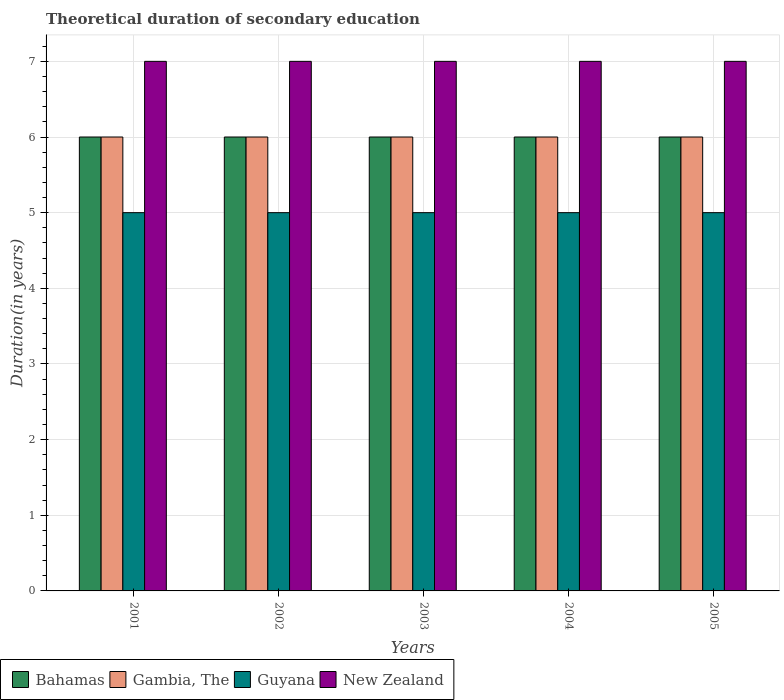How many bars are there on the 5th tick from the left?
Your answer should be compact. 4. How many bars are there on the 4th tick from the right?
Ensure brevity in your answer.  4. What is the label of the 4th group of bars from the left?
Keep it short and to the point. 2004. What is the total theoretical duration of secondary education in Gambia, The in 2004?
Your response must be concise. 6. Across all years, what is the maximum total theoretical duration of secondary education in New Zealand?
Offer a terse response. 7. In which year was the total theoretical duration of secondary education in Bahamas minimum?
Offer a very short reply. 2001. What is the total total theoretical duration of secondary education in Guyana in the graph?
Your response must be concise. 25. What is the difference between the total theoretical duration of secondary education in Bahamas in 2001 and that in 2005?
Provide a succinct answer. 0. In how many years, is the total theoretical duration of secondary education in Gambia, The greater than 1.6 years?
Make the answer very short. 5. Is the difference between the total theoretical duration of secondary education in Gambia, The in 2002 and 2005 greater than the difference between the total theoretical duration of secondary education in Bahamas in 2002 and 2005?
Keep it short and to the point. No. What is the difference between the highest and the second highest total theoretical duration of secondary education in Bahamas?
Your response must be concise. 0. What is the difference between the highest and the lowest total theoretical duration of secondary education in Gambia, The?
Offer a very short reply. 0. In how many years, is the total theoretical duration of secondary education in Gambia, The greater than the average total theoretical duration of secondary education in Gambia, The taken over all years?
Provide a short and direct response. 0. What does the 4th bar from the left in 2001 represents?
Provide a succinct answer. New Zealand. What does the 3rd bar from the right in 2002 represents?
Offer a terse response. Gambia, The. Is it the case that in every year, the sum of the total theoretical duration of secondary education in New Zealand and total theoretical duration of secondary education in Guyana is greater than the total theoretical duration of secondary education in Bahamas?
Provide a succinct answer. Yes. Are all the bars in the graph horizontal?
Give a very brief answer. No. How many years are there in the graph?
Your response must be concise. 5. What is the difference between two consecutive major ticks on the Y-axis?
Provide a short and direct response. 1. Are the values on the major ticks of Y-axis written in scientific E-notation?
Offer a terse response. No. Does the graph contain any zero values?
Give a very brief answer. No. Does the graph contain grids?
Ensure brevity in your answer.  Yes. How are the legend labels stacked?
Your answer should be very brief. Horizontal. What is the title of the graph?
Your answer should be very brief. Theoretical duration of secondary education. Does "Philippines" appear as one of the legend labels in the graph?
Provide a succinct answer. No. What is the label or title of the X-axis?
Your answer should be very brief. Years. What is the label or title of the Y-axis?
Keep it short and to the point. Duration(in years). What is the Duration(in years) of Gambia, The in 2001?
Your response must be concise. 6. What is the Duration(in years) in Guyana in 2001?
Give a very brief answer. 5. What is the Duration(in years) of Gambia, The in 2002?
Make the answer very short. 6. What is the Duration(in years) in Guyana in 2002?
Your answer should be compact. 5. What is the Duration(in years) in New Zealand in 2002?
Your response must be concise. 7. What is the Duration(in years) of Gambia, The in 2003?
Provide a succinct answer. 6. What is the Duration(in years) of Guyana in 2003?
Give a very brief answer. 5. What is the Duration(in years) of New Zealand in 2004?
Offer a terse response. 7. What is the Duration(in years) of Bahamas in 2005?
Your answer should be very brief. 6. What is the Duration(in years) of Gambia, The in 2005?
Your answer should be very brief. 6. What is the Duration(in years) of Guyana in 2005?
Your answer should be very brief. 5. Across all years, what is the maximum Duration(in years) of Bahamas?
Provide a short and direct response. 6. Across all years, what is the maximum Duration(in years) of Gambia, The?
Your response must be concise. 6. Across all years, what is the maximum Duration(in years) in New Zealand?
Ensure brevity in your answer.  7. Across all years, what is the minimum Duration(in years) in New Zealand?
Make the answer very short. 7. What is the total Duration(in years) in Bahamas in the graph?
Offer a very short reply. 30. What is the total Duration(in years) in Gambia, The in the graph?
Your response must be concise. 30. What is the total Duration(in years) of Guyana in the graph?
Offer a very short reply. 25. What is the difference between the Duration(in years) of Gambia, The in 2001 and that in 2002?
Provide a short and direct response. 0. What is the difference between the Duration(in years) of Guyana in 2001 and that in 2002?
Keep it short and to the point. 0. What is the difference between the Duration(in years) in New Zealand in 2001 and that in 2002?
Your answer should be very brief. 0. What is the difference between the Duration(in years) of Bahamas in 2001 and that in 2003?
Provide a succinct answer. 0. What is the difference between the Duration(in years) in Gambia, The in 2001 and that in 2003?
Provide a succinct answer. 0. What is the difference between the Duration(in years) in Guyana in 2001 and that in 2003?
Offer a terse response. 0. What is the difference between the Duration(in years) in Bahamas in 2001 and that in 2004?
Provide a short and direct response. 0. What is the difference between the Duration(in years) of Gambia, The in 2001 and that in 2005?
Ensure brevity in your answer.  0. What is the difference between the Duration(in years) in Gambia, The in 2002 and that in 2003?
Give a very brief answer. 0. What is the difference between the Duration(in years) of Guyana in 2002 and that in 2003?
Your response must be concise. 0. What is the difference between the Duration(in years) of New Zealand in 2002 and that in 2003?
Offer a terse response. 0. What is the difference between the Duration(in years) in Gambia, The in 2002 and that in 2004?
Give a very brief answer. 0. What is the difference between the Duration(in years) in Guyana in 2002 and that in 2004?
Offer a very short reply. 0. What is the difference between the Duration(in years) of Bahamas in 2002 and that in 2005?
Your response must be concise. 0. What is the difference between the Duration(in years) in Gambia, The in 2002 and that in 2005?
Offer a very short reply. 0. What is the difference between the Duration(in years) in Guyana in 2002 and that in 2005?
Offer a very short reply. 0. What is the difference between the Duration(in years) in New Zealand in 2002 and that in 2005?
Your response must be concise. 0. What is the difference between the Duration(in years) of Bahamas in 2003 and that in 2004?
Ensure brevity in your answer.  0. What is the difference between the Duration(in years) of Gambia, The in 2003 and that in 2004?
Your answer should be very brief. 0. What is the difference between the Duration(in years) of Bahamas in 2003 and that in 2005?
Provide a short and direct response. 0. What is the difference between the Duration(in years) in New Zealand in 2003 and that in 2005?
Keep it short and to the point. 0. What is the difference between the Duration(in years) of Gambia, The in 2004 and that in 2005?
Provide a succinct answer. 0. What is the difference between the Duration(in years) of Bahamas in 2001 and the Duration(in years) of Gambia, The in 2002?
Your response must be concise. 0. What is the difference between the Duration(in years) of Bahamas in 2001 and the Duration(in years) of Guyana in 2002?
Provide a short and direct response. 1. What is the difference between the Duration(in years) of Gambia, The in 2001 and the Duration(in years) of Guyana in 2002?
Offer a very short reply. 1. What is the difference between the Duration(in years) of Bahamas in 2001 and the Duration(in years) of Gambia, The in 2003?
Offer a very short reply. 0. What is the difference between the Duration(in years) of Bahamas in 2001 and the Duration(in years) of Gambia, The in 2004?
Give a very brief answer. 0. What is the difference between the Duration(in years) of Bahamas in 2001 and the Duration(in years) of Guyana in 2004?
Offer a terse response. 1. What is the difference between the Duration(in years) of Guyana in 2001 and the Duration(in years) of New Zealand in 2004?
Your answer should be compact. -2. What is the difference between the Duration(in years) in Gambia, The in 2001 and the Duration(in years) in Guyana in 2005?
Keep it short and to the point. 1. What is the difference between the Duration(in years) of Gambia, The in 2001 and the Duration(in years) of New Zealand in 2005?
Provide a succinct answer. -1. What is the difference between the Duration(in years) of Guyana in 2001 and the Duration(in years) of New Zealand in 2005?
Give a very brief answer. -2. What is the difference between the Duration(in years) of Gambia, The in 2002 and the Duration(in years) of Guyana in 2003?
Keep it short and to the point. 1. What is the difference between the Duration(in years) in Bahamas in 2002 and the Duration(in years) in Gambia, The in 2004?
Provide a succinct answer. 0. What is the difference between the Duration(in years) of Bahamas in 2002 and the Duration(in years) of Guyana in 2004?
Give a very brief answer. 1. What is the difference between the Duration(in years) in Bahamas in 2002 and the Duration(in years) in New Zealand in 2004?
Your response must be concise. -1. What is the difference between the Duration(in years) of Gambia, The in 2002 and the Duration(in years) of Guyana in 2004?
Your answer should be compact. 1. What is the difference between the Duration(in years) of Gambia, The in 2002 and the Duration(in years) of New Zealand in 2004?
Provide a succinct answer. -1. What is the difference between the Duration(in years) of Gambia, The in 2002 and the Duration(in years) of Guyana in 2005?
Make the answer very short. 1. What is the difference between the Duration(in years) in Bahamas in 2003 and the Duration(in years) in Gambia, The in 2004?
Provide a succinct answer. 0. What is the difference between the Duration(in years) in Bahamas in 2003 and the Duration(in years) in Guyana in 2004?
Your answer should be very brief. 1. What is the difference between the Duration(in years) in Gambia, The in 2003 and the Duration(in years) in Guyana in 2004?
Keep it short and to the point. 1. What is the difference between the Duration(in years) of Gambia, The in 2003 and the Duration(in years) of New Zealand in 2004?
Make the answer very short. -1. What is the difference between the Duration(in years) in Bahamas in 2003 and the Duration(in years) in Guyana in 2005?
Your response must be concise. 1. What is the difference between the Duration(in years) in Bahamas in 2003 and the Duration(in years) in New Zealand in 2005?
Keep it short and to the point. -1. What is the difference between the Duration(in years) of Gambia, The in 2003 and the Duration(in years) of New Zealand in 2005?
Provide a succinct answer. -1. What is the difference between the Duration(in years) in Guyana in 2003 and the Duration(in years) in New Zealand in 2005?
Keep it short and to the point. -2. What is the difference between the Duration(in years) in Bahamas in 2004 and the Duration(in years) in Guyana in 2005?
Keep it short and to the point. 1. What is the difference between the Duration(in years) of Bahamas in 2004 and the Duration(in years) of New Zealand in 2005?
Your answer should be very brief. -1. What is the difference between the Duration(in years) of Gambia, The in 2004 and the Duration(in years) of New Zealand in 2005?
Provide a succinct answer. -1. What is the average Duration(in years) of Gambia, The per year?
Give a very brief answer. 6. What is the average Duration(in years) in Guyana per year?
Ensure brevity in your answer.  5. In the year 2001, what is the difference between the Duration(in years) of Bahamas and Duration(in years) of Gambia, The?
Offer a terse response. 0. In the year 2001, what is the difference between the Duration(in years) of Bahamas and Duration(in years) of Guyana?
Offer a very short reply. 1. In the year 2001, what is the difference between the Duration(in years) in Guyana and Duration(in years) in New Zealand?
Offer a very short reply. -2. In the year 2002, what is the difference between the Duration(in years) of Bahamas and Duration(in years) of Guyana?
Your response must be concise. 1. In the year 2002, what is the difference between the Duration(in years) in Gambia, The and Duration(in years) in New Zealand?
Your response must be concise. -1. In the year 2002, what is the difference between the Duration(in years) in Guyana and Duration(in years) in New Zealand?
Give a very brief answer. -2. In the year 2003, what is the difference between the Duration(in years) in Bahamas and Duration(in years) in Guyana?
Give a very brief answer. 1. In the year 2003, what is the difference between the Duration(in years) in Gambia, The and Duration(in years) in Guyana?
Give a very brief answer. 1. In the year 2004, what is the difference between the Duration(in years) in Bahamas and Duration(in years) in Gambia, The?
Provide a succinct answer. 0. In the year 2004, what is the difference between the Duration(in years) in Bahamas and Duration(in years) in Guyana?
Provide a short and direct response. 1. In the year 2004, what is the difference between the Duration(in years) in Bahamas and Duration(in years) in New Zealand?
Offer a terse response. -1. In the year 2004, what is the difference between the Duration(in years) of Gambia, The and Duration(in years) of New Zealand?
Make the answer very short. -1. In the year 2004, what is the difference between the Duration(in years) of Guyana and Duration(in years) of New Zealand?
Offer a terse response. -2. In the year 2005, what is the difference between the Duration(in years) of Bahamas and Duration(in years) of Gambia, The?
Give a very brief answer. 0. In the year 2005, what is the difference between the Duration(in years) of Gambia, The and Duration(in years) of New Zealand?
Keep it short and to the point. -1. In the year 2005, what is the difference between the Duration(in years) of Guyana and Duration(in years) of New Zealand?
Offer a terse response. -2. What is the ratio of the Duration(in years) of Gambia, The in 2001 to that in 2002?
Offer a very short reply. 1. What is the ratio of the Duration(in years) of New Zealand in 2001 to that in 2002?
Ensure brevity in your answer.  1. What is the ratio of the Duration(in years) of Bahamas in 2001 to that in 2003?
Make the answer very short. 1. What is the ratio of the Duration(in years) in Gambia, The in 2001 to that in 2003?
Offer a terse response. 1. What is the ratio of the Duration(in years) in New Zealand in 2001 to that in 2003?
Your response must be concise. 1. What is the ratio of the Duration(in years) in New Zealand in 2001 to that in 2004?
Provide a short and direct response. 1. What is the ratio of the Duration(in years) of Gambia, The in 2001 to that in 2005?
Provide a short and direct response. 1. What is the ratio of the Duration(in years) of New Zealand in 2002 to that in 2003?
Ensure brevity in your answer.  1. What is the ratio of the Duration(in years) in Bahamas in 2002 to that in 2004?
Your response must be concise. 1. What is the ratio of the Duration(in years) of Guyana in 2002 to that in 2004?
Your response must be concise. 1. What is the ratio of the Duration(in years) of New Zealand in 2002 to that in 2004?
Your answer should be very brief. 1. What is the ratio of the Duration(in years) of Bahamas in 2002 to that in 2005?
Give a very brief answer. 1. What is the ratio of the Duration(in years) of Gambia, The in 2002 to that in 2005?
Your answer should be compact. 1. What is the ratio of the Duration(in years) in Guyana in 2002 to that in 2005?
Give a very brief answer. 1. What is the ratio of the Duration(in years) of New Zealand in 2002 to that in 2005?
Offer a terse response. 1. What is the ratio of the Duration(in years) of Bahamas in 2003 to that in 2004?
Provide a succinct answer. 1. What is the ratio of the Duration(in years) of Gambia, The in 2003 to that in 2004?
Your response must be concise. 1. What is the ratio of the Duration(in years) in Guyana in 2003 to that in 2004?
Offer a terse response. 1. What is the ratio of the Duration(in years) in Guyana in 2003 to that in 2005?
Keep it short and to the point. 1. What is the ratio of the Duration(in years) of New Zealand in 2003 to that in 2005?
Make the answer very short. 1. What is the ratio of the Duration(in years) in Gambia, The in 2004 to that in 2005?
Your answer should be compact. 1. What is the ratio of the Duration(in years) of Guyana in 2004 to that in 2005?
Offer a very short reply. 1. What is the difference between the highest and the second highest Duration(in years) of Gambia, The?
Offer a terse response. 0. What is the difference between the highest and the second highest Duration(in years) in Guyana?
Give a very brief answer. 0. What is the difference between the highest and the second highest Duration(in years) of New Zealand?
Give a very brief answer. 0. 